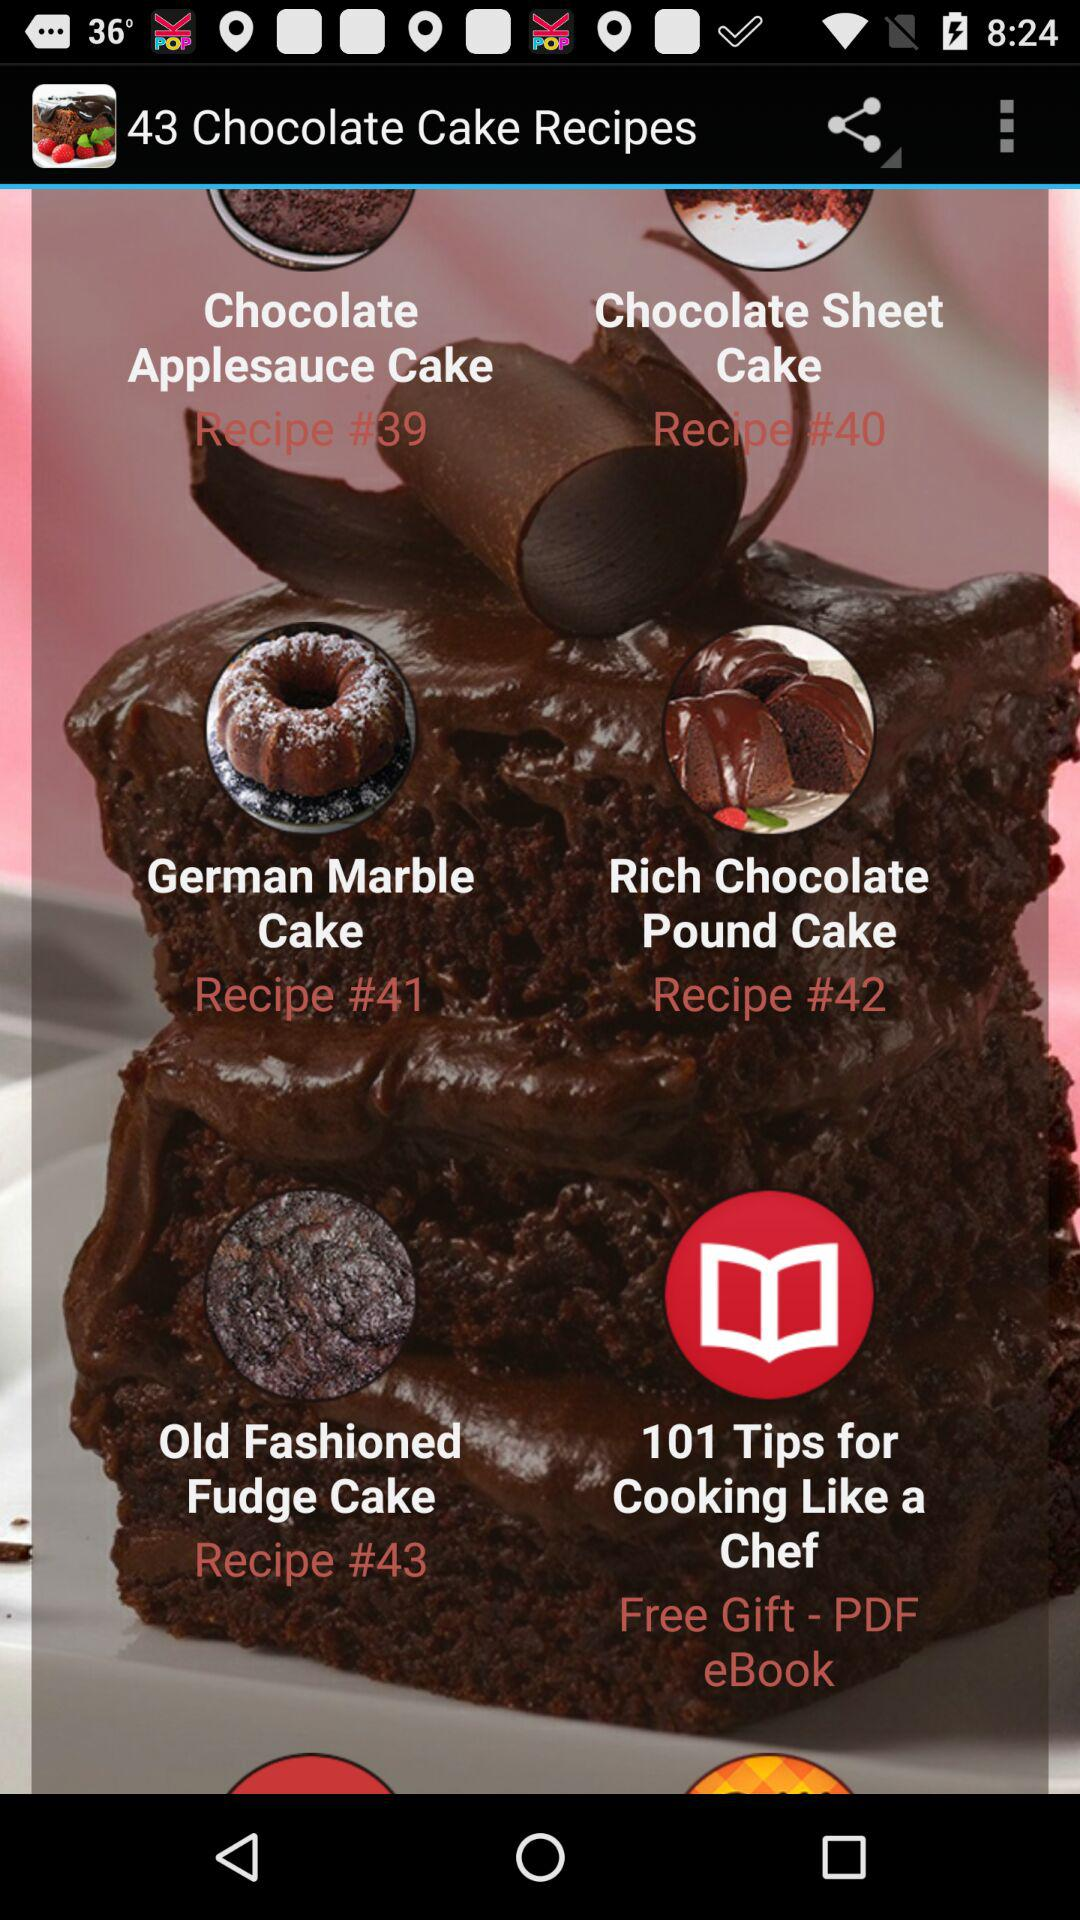What is the recipe number for the German Marble Cake? The recipe number for the German Marble Cake is 41. 